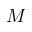<formula> <loc_0><loc_0><loc_500><loc_500>M</formula> 